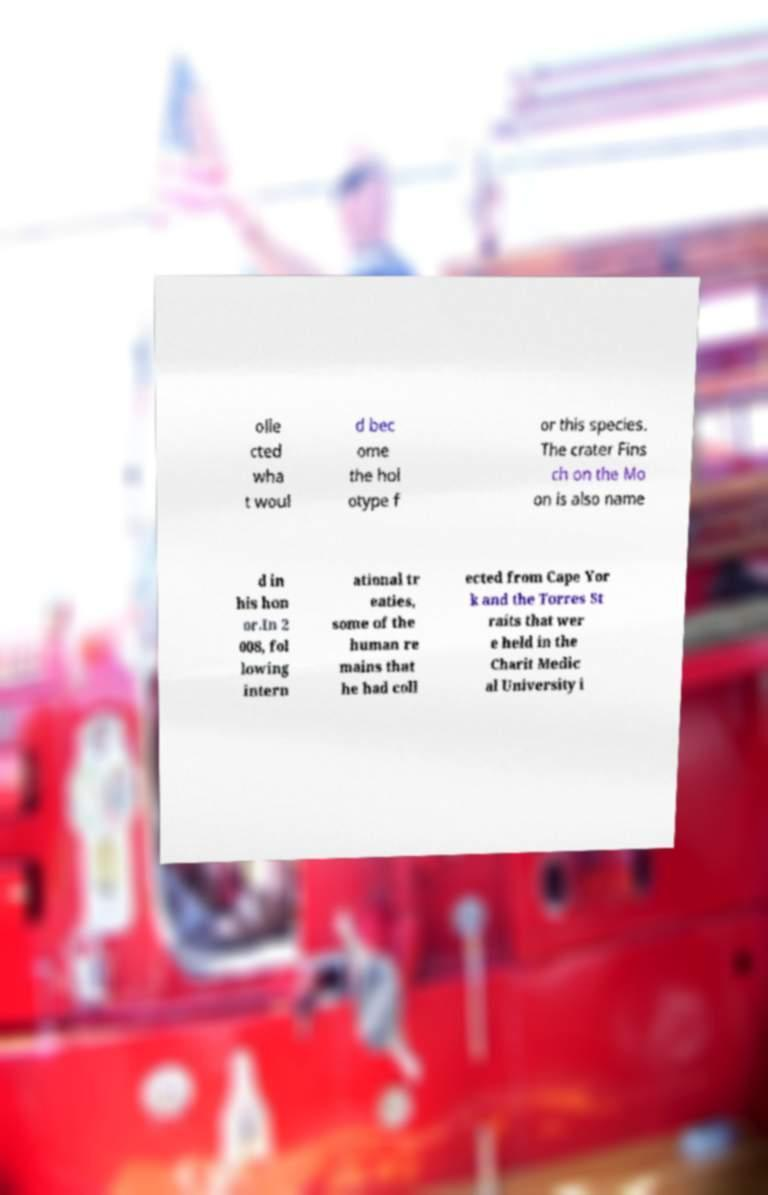Could you assist in decoding the text presented in this image and type it out clearly? olle cted wha t woul d bec ome the hol otype f or this species. The crater Fins ch on the Mo on is also name d in his hon or.In 2 008, fol lowing intern ational tr eaties, some of the human re mains that he had coll ected from Cape Yor k and the Torres St raits that wer e held in the Charit Medic al University i 